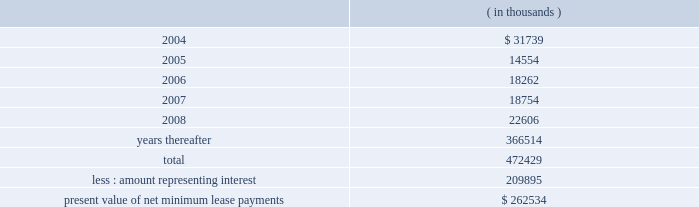Entergy corporation notes to consolidated financial statements sale and leaseback transactions waterford 3 lease obligations in 1989 , entergy louisiana sold and leased back 9.3% ( 9.3 % ) of its interest in waterford 3 for the aggregate sum of $ 353.6 million .
The lease has an approximate term of 28 years .
The lessors financed the sale-leaseback through the issuance of waterford 3 secured lease obligation bonds .
The lease payments made by entergy louisiana are sufficient to service the debt .
In 1994 , entergy louisiana did not exercise its option to repurchase the 9.3% ( 9.3 % ) interest in waterford 3 .
As a result , entergy louisiana issued $ 208.2 million of non-interest bearing first mortgage bonds as collateral for the equity portion of certain amounts payable under the lease .
In 1997 , the lessors refinanced the outstanding bonds used to finance the purchase of waterford 3 at lower interest rates , which reduced the annual lease payments .
Upon the occurrence of certain events , entergy louisiana may be obligated to assume the outstanding bonds used to finance the purchase of the unit and to pay an amount sufficient to withdraw from the lease transaction .
Such events include lease events of default , events of loss , deemed loss events , or certain adverse "financial events." "financial events" include , among other things , failure by entergy louisiana , following the expiration of any applicable grace or cure period , to maintain ( i ) total equity capital ( including preferred stock ) at least equal to 30% ( 30 % ) of adjusted capitalization , or ( ii ) a fixed charge coverage ratio of at least 1.50 computed on a rolling 12 month basis .
As of december 31 , 2003 , entergy louisiana's total equity capital ( including preferred stock ) was 49.82% ( 49.82 % ) of adjusted capitalization and its fixed charge coverage ratio for 2003 was 4.06 .
As of december 31 , 2003 , entergy louisiana had future minimum lease payments ( reflecting an overall implicit rate of 7.45% ( 7.45 % ) ) in connection with the waterford 3 sale and leaseback transactions , which are recorded as long-term debt , as follows: .
Grand gulf 1 lease obligations in december 1988 , system energy sold 11.5% ( 11.5 % ) of its undivided ownership interest in grand gulf 1 for the aggregate sum of $ 500 million .
Subsequently , system energy leased back its interest in the unit for a term of 26-1/2 years .
System energy has the option of terminating the lease and repurchasing the 11.5% ( 11.5 % ) interest in the unit at certain intervals during the lease .
Furthermore , at the end of the lease term , system energy has the option of renewing the lease or repurchasing the 11.5% ( 11.5 % ) interest in grand gulf 1 .
System energy is required to report the sale-leaseback as a financing transaction in its financial statements .
For financial reporting purposes , system energy expenses the interest portion of the lease obligation and the plant .
What portion of the total future minimum lease payments for entergy louisiana is due within the next 12 months? 
Computations: (31739 / 472429)
Answer: 0.06718. Entergy corporation notes to consolidated financial statements sale and leaseback transactions waterford 3 lease obligations in 1989 , entergy louisiana sold and leased back 9.3% ( 9.3 % ) of its interest in waterford 3 for the aggregate sum of $ 353.6 million .
The lease has an approximate term of 28 years .
The lessors financed the sale-leaseback through the issuance of waterford 3 secured lease obligation bonds .
The lease payments made by entergy louisiana are sufficient to service the debt .
In 1994 , entergy louisiana did not exercise its option to repurchase the 9.3% ( 9.3 % ) interest in waterford 3 .
As a result , entergy louisiana issued $ 208.2 million of non-interest bearing first mortgage bonds as collateral for the equity portion of certain amounts payable under the lease .
In 1997 , the lessors refinanced the outstanding bonds used to finance the purchase of waterford 3 at lower interest rates , which reduced the annual lease payments .
Upon the occurrence of certain events , entergy louisiana may be obligated to assume the outstanding bonds used to finance the purchase of the unit and to pay an amount sufficient to withdraw from the lease transaction .
Such events include lease events of default , events of loss , deemed loss events , or certain adverse "financial events." "financial events" include , among other things , failure by entergy louisiana , following the expiration of any applicable grace or cure period , to maintain ( i ) total equity capital ( including preferred stock ) at least equal to 30% ( 30 % ) of adjusted capitalization , or ( ii ) a fixed charge coverage ratio of at least 1.50 computed on a rolling 12 month basis .
As of december 31 , 2003 , entergy louisiana's total equity capital ( including preferred stock ) was 49.82% ( 49.82 % ) of adjusted capitalization and its fixed charge coverage ratio for 2003 was 4.06 .
As of december 31 , 2003 , entergy louisiana had future minimum lease payments ( reflecting an overall implicit rate of 7.45% ( 7.45 % ) ) in connection with the waterford 3 sale and leaseback transactions , which are recorded as long-term debt , as follows: .
Grand gulf 1 lease obligations in december 1988 , system energy sold 11.5% ( 11.5 % ) of its undivided ownership interest in grand gulf 1 for the aggregate sum of $ 500 million .
Subsequently , system energy leased back its interest in the unit for a term of 26-1/2 years .
System energy has the option of terminating the lease and repurchasing the 11.5% ( 11.5 % ) interest in the unit at certain intervals during the lease .
Furthermore , at the end of the lease term , system energy has the option of renewing the lease or repurchasing the 11.5% ( 11.5 % ) interest in grand gulf 1 .
System energy is required to report the sale-leaseback as a financing transaction in its financial statements .
For financial reporting purposes , system energy expenses the interest portion of the lease obligation and the plant .
What portion of the total future minimum lease payments for entergy louisiana is used for interest? 
Computations: (209895 / 472429)
Answer: 0.44429. 